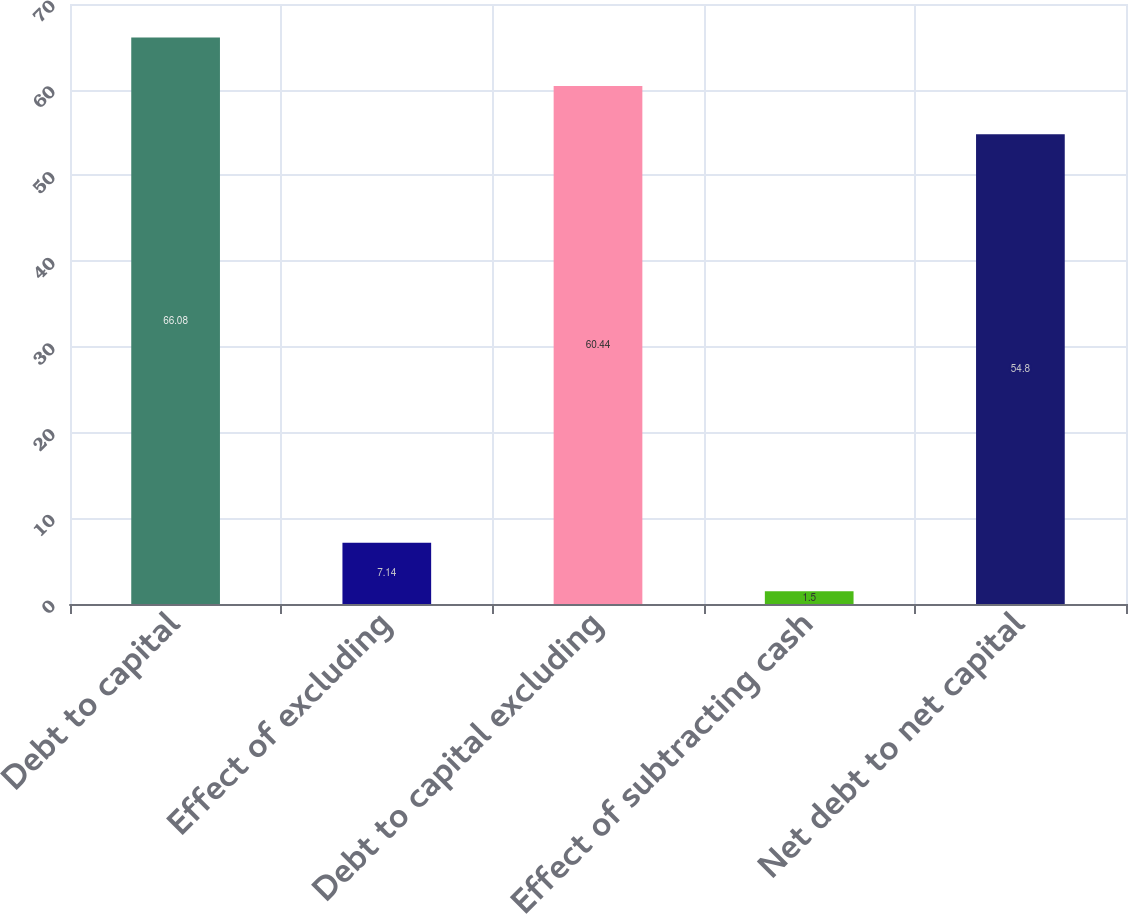Convert chart to OTSL. <chart><loc_0><loc_0><loc_500><loc_500><bar_chart><fcel>Debt to capital<fcel>Effect of excluding<fcel>Debt to capital excluding<fcel>Effect of subtracting cash<fcel>Net debt to net capital<nl><fcel>66.08<fcel>7.14<fcel>60.44<fcel>1.5<fcel>54.8<nl></chart> 